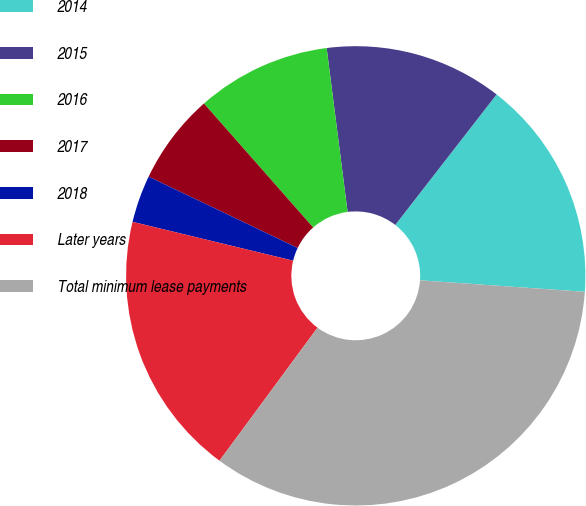Convert chart to OTSL. <chart><loc_0><loc_0><loc_500><loc_500><pie_chart><fcel>2014<fcel>2015<fcel>2016<fcel>2017<fcel>2018<fcel>Later years<fcel>Total minimum lease payments<nl><fcel>15.6%<fcel>12.53%<fcel>9.47%<fcel>6.4%<fcel>3.33%<fcel>18.67%<fcel>34.0%<nl></chart> 